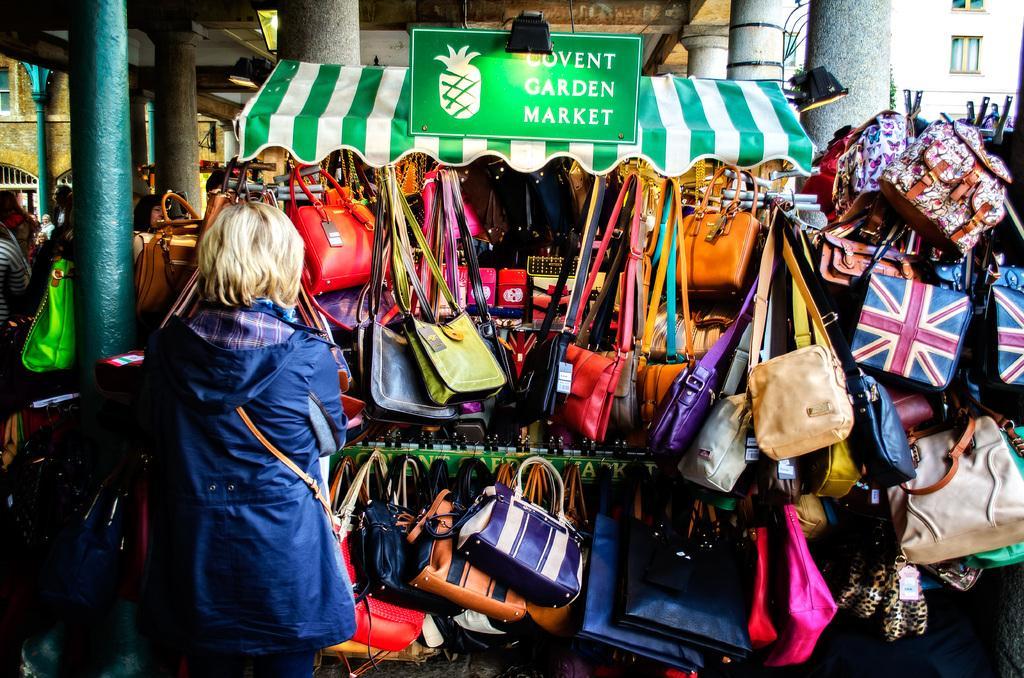In one or two sentences, can you explain what this image depicts? In this image in the center there are a group of handbags and one woman is standing, and in the background there are some buildings, pillars and some board and lights. And on the board there is some text. 